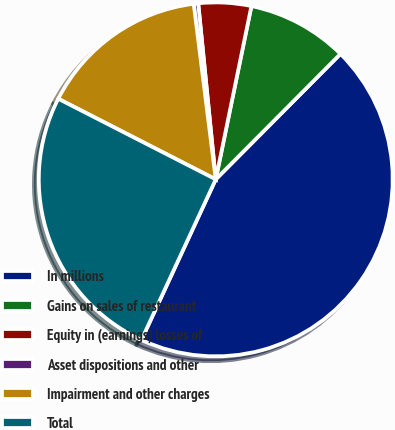Convert chart. <chart><loc_0><loc_0><loc_500><loc_500><pie_chart><fcel>In millions<fcel>Gains on sales of restaurant<fcel>Equity in (earnings) losses of<fcel>Asset dispositions and other<fcel>Impairment and other charges<fcel>Total<nl><fcel>44.44%<fcel>9.22%<fcel>4.81%<fcel>0.41%<fcel>15.48%<fcel>25.63%<nl></chart> 